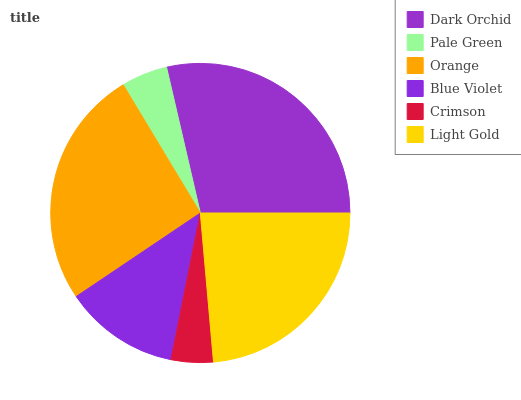Is Crimson the minimum?
Answer yes or no. Yes. Is Dark Orchid the maximum?
Answer yes or no. Yes. Is Pale Green the minimum?
Answer yes or no. No. Is Pale Green the maximum?
Answer yes or no. No. Is Dark Orchid greater than Pale Green?
Answer yes or no. Yes. Is Pale Green less than Dark Orchid?
Answer yes or no. Yes. Is Pale Green greater than Dark Orchid?
Answer yes or no. No. Is Dark Orchid less than Pale Green?
Answer yes or no. No. Is Light Gold the high median?
Answer yes or no. Yes. Is Blue Violet the low median?
Answer yes or no. Yes. Is Pale Green the high median?
Answer yes or no. No. Is Orange the low median?
Answer yes or no. No. 